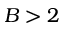Convert formula to latex. <formula><loc_0><loc_0><loc_500><loc_500>B > 2</formula> 